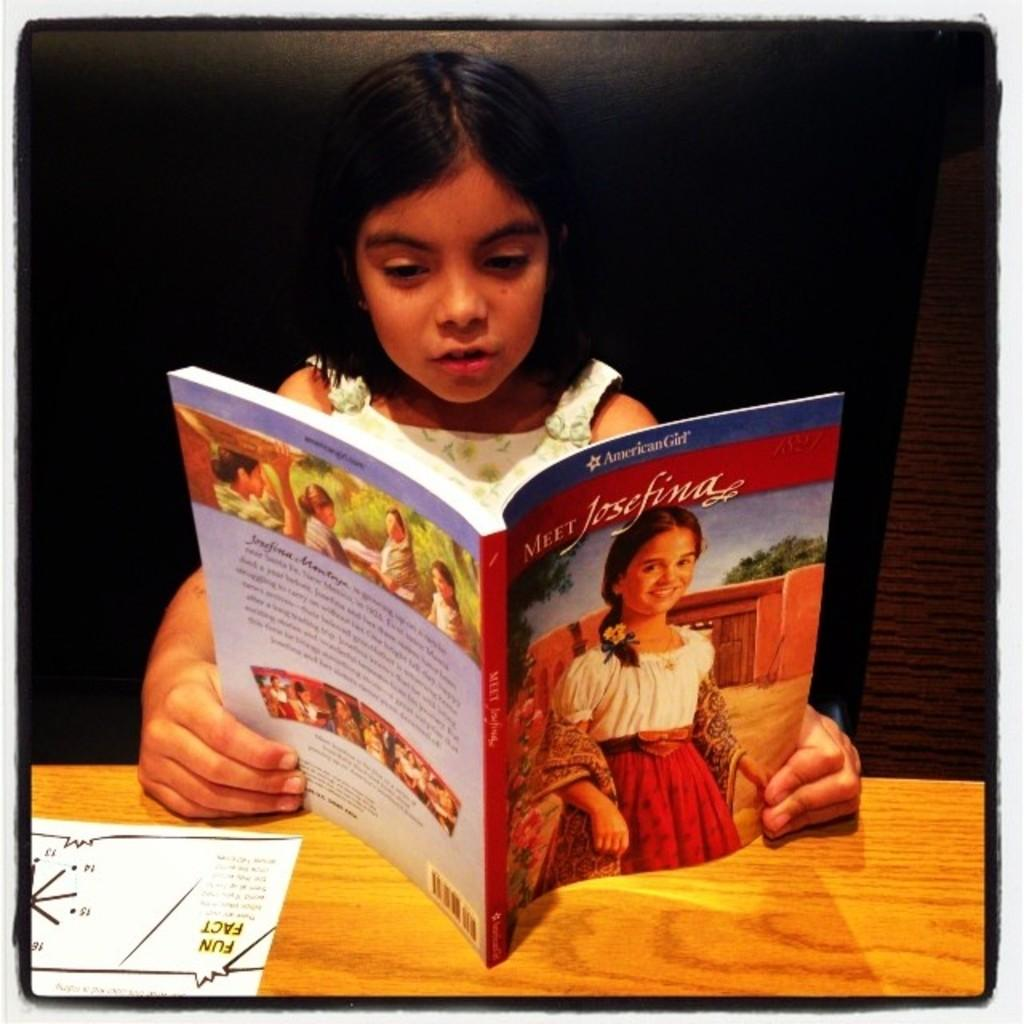<image>
Summarize the visual content of the image. Girl holding and reading American Girl book with two hands while sitting down. 